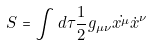Convert formula to latex. <formula><loc_0><loc_0><loc_500><loc_500>S = \int { d \tau \frac { 1 } { 2 } g _ { \mu \nu } \dot { x ^ { \mu } } { \dot { x } ^ { \nu } } }</formula> 